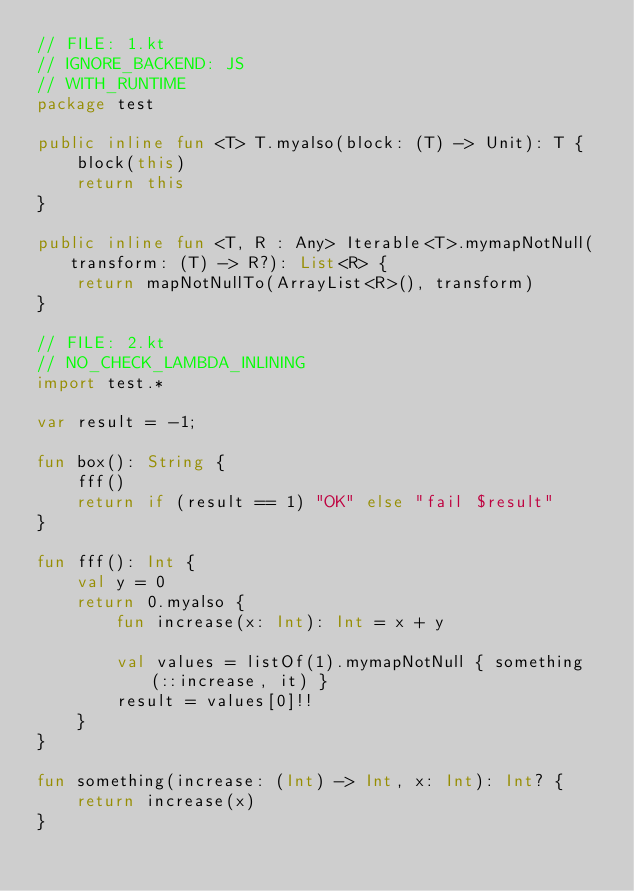<code> <loc_0><loc_0><loc_500><loc_500><_Kotlin_>// FILE: 1.kt
// IGNORE_BACKEND: JS
// WITH_RUNTIME
package test

public inline fun <T> T.myalso(block: (T) -> Unit): T {
    block(this)
    return this
}

public inline fun <T, R : Any> Iterable<T>.mymapNotNull(transform: (T) -> R?): List<R> {
    return mapNotNullTo(ArrayList<R>(), transform)
}

// FILE: 2.kt
// NO_CHECK_LAMBDA_INLINING
import test.*

var result = -1;

fun box(): String {
    fff()
    return if (result == 1) "OK" else "fail $result"
}

fun fff(): Int {
    val y = 0
    return 0.myalso {
        fun increase(x: Int): Int = x + y

        val values = listOf(1).mymapNotNull { something(::increase, it) }
        result = values[0]!!
    }
}

fun something(increase: (Int) -> Int, x: Int): Int? {
    return increase(x)
}</code> 